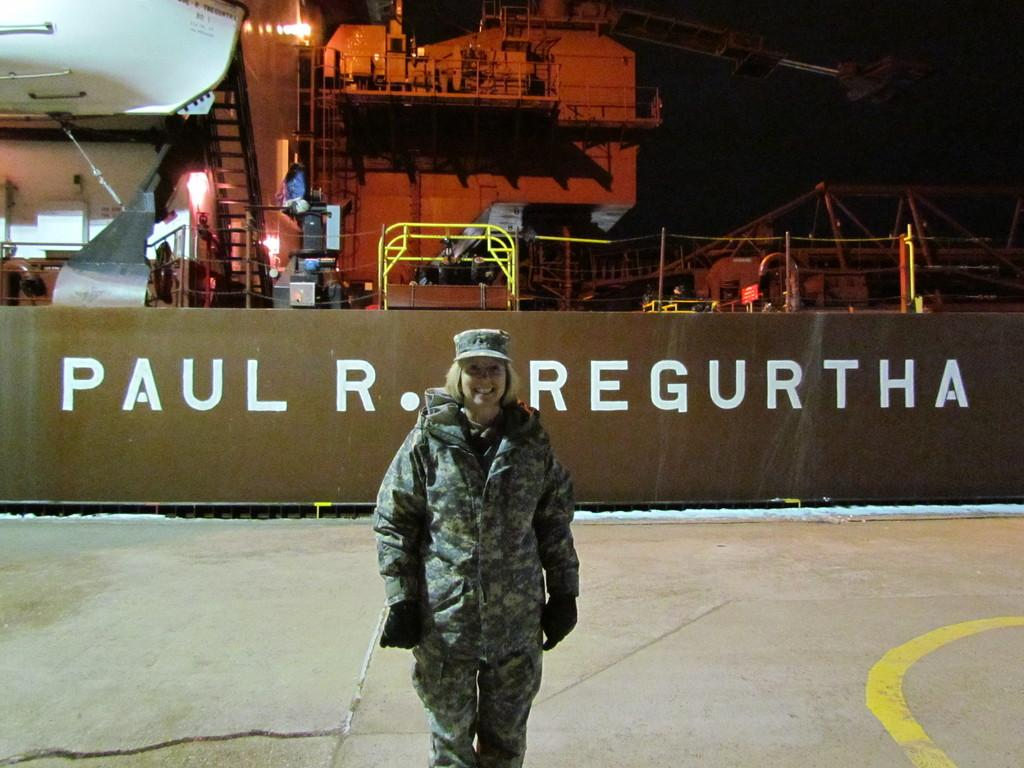Who is present in the image? There is a woman in the image. What is the woman doing in the image? The woman is smiling in the image. What accessories is the woman wearing? The woman is wearing a cap on her head and gloves on her hands. What else can be seen in the image besides the woman? There is a ship in the image. What is written or displayed on the ship? There is text on the ship. What type of bead is the woman using to write in the image? There is no bead present in the image, nor is the woman writing anything. 